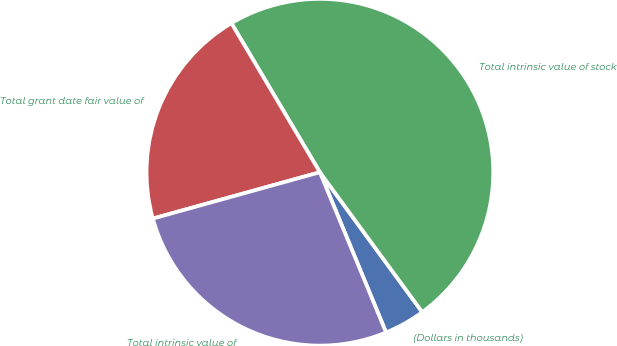<chart> <loc_0><loc_0><loc_500><loc_500><pie_chart><fcel>(Dollars in thousands)<fcel>Total intrinsic value of stock<fcel>Total grant date fair value of<fcel>Total intrinsic value of<nl><fcel>3.82%<fcel>48.47%<fcel>20.78%<fcel>26.93%<nl></chart> 